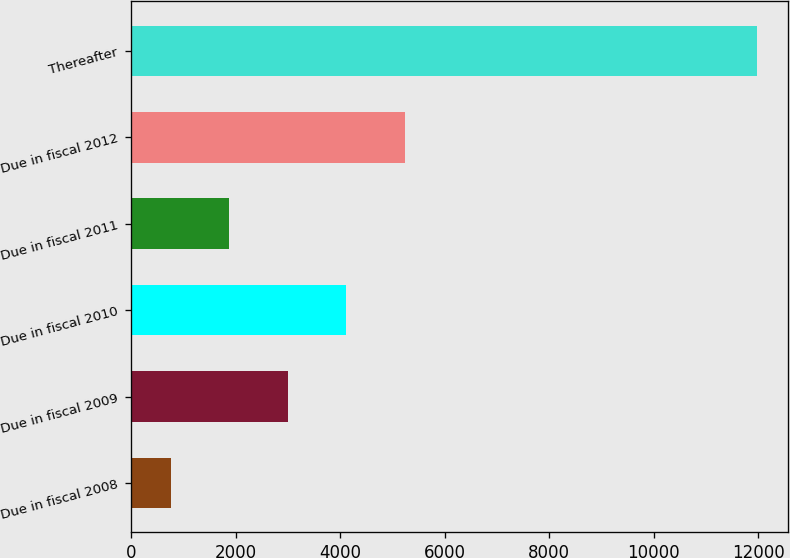Convert chart. <chart><loc_0><loc_0><loc_500><loc_500><bar_chart><fcel>Due in fiscal 2008<fcel>Due in fiscal 2009<fcel>Due in fiscal 2010<fcel>Due in fiscal 2011<fcel>Due in fiscal 2012<fcel>Thereafter<nl><fcel>757<fcel>3001.2<fcel>4123.3<fcel>1879.1<fcel>5245.4<fcel>11978<nl></chart> 